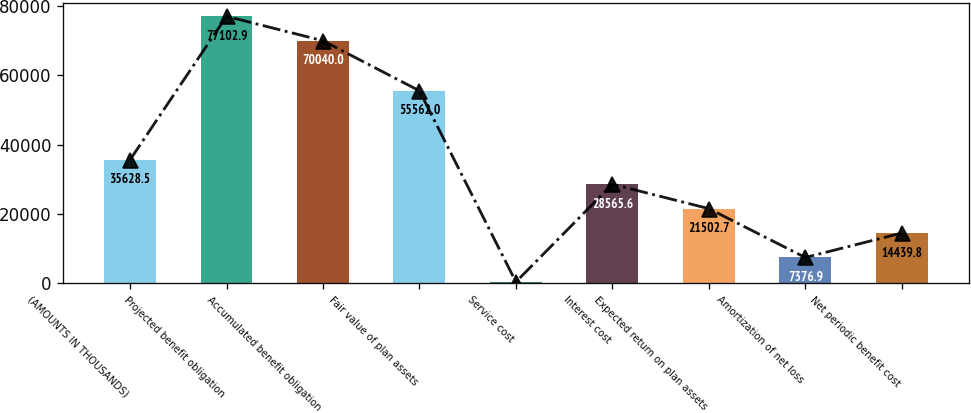<chart> <loc_0><loc_0><loc_500><loc_500><bar_chart><fcel>(AMOUNTS IN THOUSANDS)<fcel>Projected benefit obligation<fcel>Accumulated benefit obligation<fcel>Fair value of plan assets<fcel>Service cost<fcel>Interest cost<fcel>Expected return on plan assets<fcel>Amortization of net loss<fcel>Net periodic benefit cost<nl><fcel>35628.5<fcel>77102.9<fcel>70040<fcel>55562<fcel>314<fcel>28565.6<fcel>21502.7<fcel>7376.9<fcel>14439.8<nl></chart> 